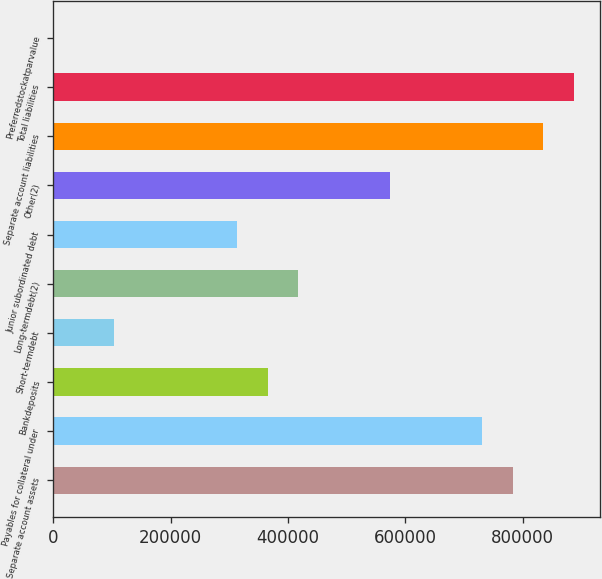Convert chart. <chart><loc_0><loc_0><loc_500><loc_500><bar_chart><fcel>Separate account assets<fcel>Payables for collateral under<fcel>Bankdeposits<fcel>Short-termdebt<fcel>Long-termdebt(2)<fcel>Junior subordinated debt<fcel>Other(2)<fcel>Separate account liabilities<fcel>Total liabilities<fcel>Preferredstockatparvalue<nl><fcel>783246<fcel>731029<fcel>365515<fcel>104434<fcel>417731<fcel>313299<fcel>574380<fcel>835462<fcel>887678<fcel>1<nl></chart> 